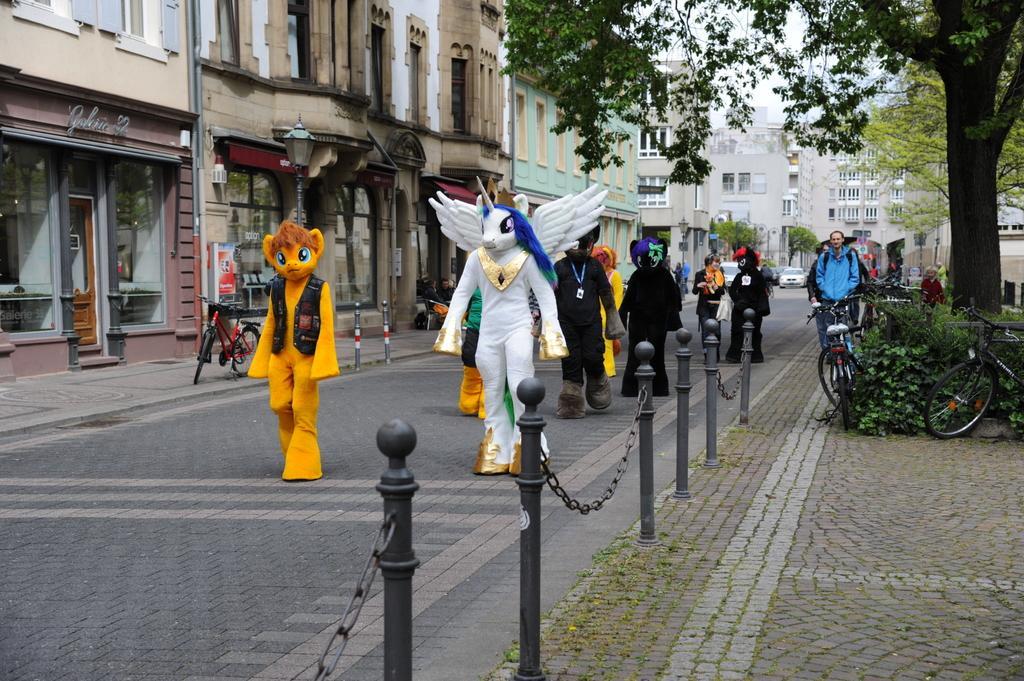Describe this image in one or two sentences. In this picture we can see some people are wearing different costume and walking on the road, beside we can see some buildings and trees. 